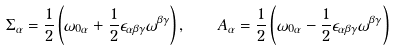<formula> <loc_0><loc_0><loc_500><loc_500>\Sigma _ { \alpha } = \frac { 1 } { 2 } \left ( \omega _ { 0 \alpha } + \frac { 1 } { 2 } \epsilon _ { \alpha \beta \gamma } \omega ^ { \beta \gamma } \right ) , \quad A _ { \alpha } = \frac { 1 } { 2 } \left ( \omega _ { 0 \alpha } - \frac { 1 } { 2 } \epsilon _ { \alpha \beta \gamma } \omega ^ { \beta \gamma } \right )</formula> 